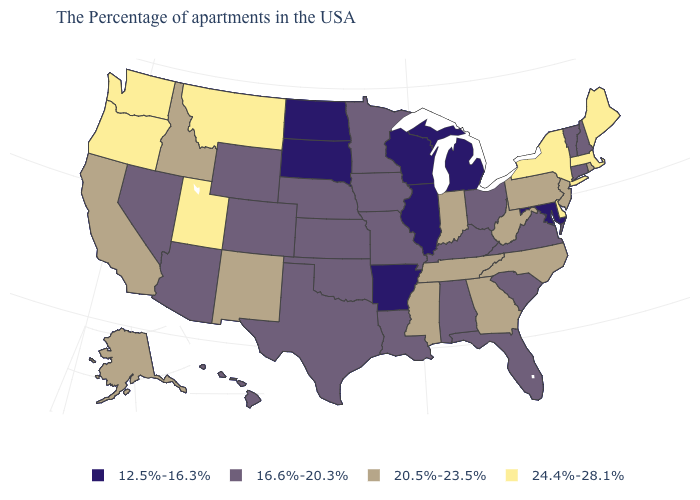What is the highest value in the Northeast ?
Answer briefly. 24.4%-28.1%. Is the legend a continuous bar?
Short answer required. No. Which states have the lowest value in the USA?
Write a very short answer. Maryland, Michigan, Wisconsin, Illinois, Arkansas, South Dakota, North Dakota. Which states have the lowest value in the USA?
Answer briefly. Maryland, Michigan, Wisconsin, Illinois, Arkansas, South Dakota, North Dakota. Does the map have missing data?
Answer briefly. No. Among the states that border Alabama , which have the highest value?
Concise answer only. Georgia, Tennessee, Mississippi. Does South Dakota have the lowest value in the USA?
Be succinct. Yes. Does South Dakota have the highest value in the MidWest?
Quick response, please. No. What is the value of North Carolina?
Concise answer only. 20.5%-23.5%. Does Massachusetts have the highest value in the Northeast?
Give a very brief answer. Yes. What is the highest value in the USA?
Concise answer only. 24.4%-28.1%. What is the highest value in states that border Georgia?
Answer briefly. 20.5%-23.5%. What is the highest value in the South ?
Answer briefly. 24.4%-28.1%. Which states hav the highest value in the South?
Give a very brief answer. Delaware. Name the states that have a value in the range 24.4%-28.1%?
Concise answer only. Maine, Massachusetts, New York, Delaware, Utah, Montana, Washington, Oregon. 